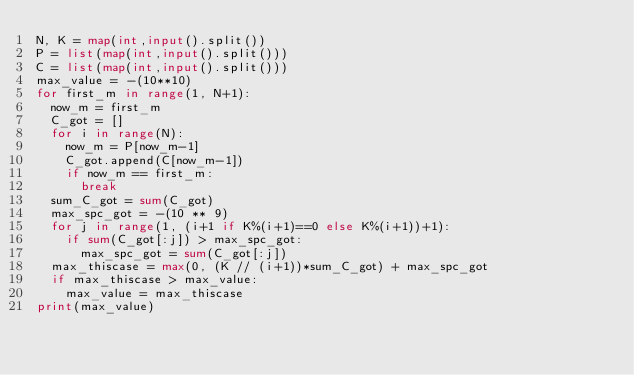Convert code to text. <code><loc_0><loc_0><loc_500><loc_500><_Python_>N, K = map(int,input().split())
P = list(map(int,input().split()))
C = list(map(int,input().split()))
max_value = -(10**10)
for first_m in range(1, N+1):
  now_m = first_m
  C_got = []
  for i in range(N):
    now_m = P[now_m-1]
    C_got.append(C[now_m-1])
    if now_m == first_m:
      break
  sum_C_got = sum(C_got)
  max_spc_got = -(10 ** 9)
  for j in range(1, (i+1 if K%(i+1)==0 else K%(i+1))+1):
    if sum(C_got[:j]) > max_spc_got:
      max_spc_got = sum(C_got[:j])
  max_thiscase = max(0, (K // (i+1))*sum_C_got) + max_spc_got
  if max_thiscase > max_value:
    max_value = max_thiscase
print(max_value)
    
    </code> 